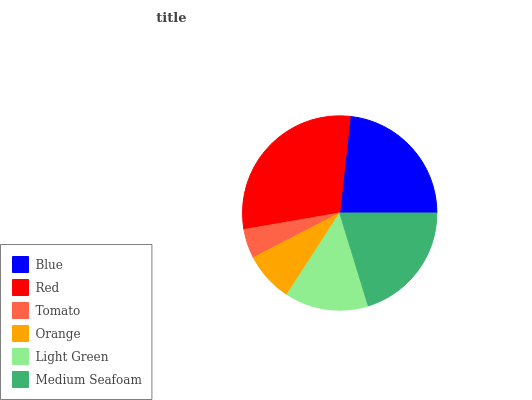Is Tomato the minimum?
Answer yes or no. Yes. Is Red the maximum?
Answer yes or no. Yes. Is Red the minimum?
Answer yes or no. No. Is Tomato the maximum?
Answer yes or no. No. Is Red greater than Tomato?
Answer yes or no. Yes. Is Tomato less than Red?
Answer yes or no. Yes. Is Tomato greater than Red?
Answer yes or no. No. Is Red less than Tomato?
Answer yes or no. No. Is Medium Seafoam the high median?
Answer yes or no. Yes. Is Light Green the low median?
Answer yes or no. Yes. Is Orange the high median?
Answer yes or no. No. Is Tomato the low median?
Answer yes or no. No. 